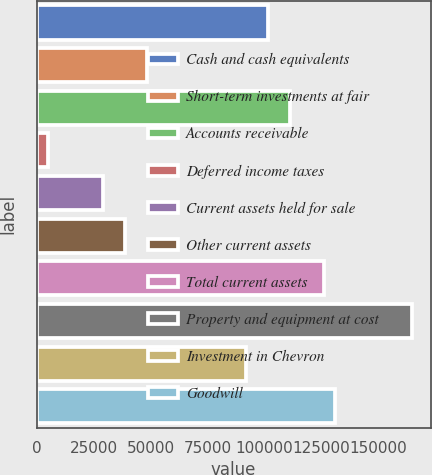Convert chart to OTSL. <chart><loc_0><loc_0><loc_500><loc_500><bar_chart><fcel>Cash and cash equivalents<fcel>Short-term investments at fair<fcel>Accounts receivable<fcel>Deferred income taxes<fcel>Current assets held for sale<fcel>Other current assets<fcel>Total current assets<fcel>Property and equipment at cost<fcel>Investment in Chevron<fcel>Goodwill<nl><fcel>101792<fcel>48473<fcel>111487<fcel>4848.2<fcel>29084.2<fcel>38778.6<fcel>126028<fcel>164806<fcel>92097.8<fcel>130875<nl></chart> 